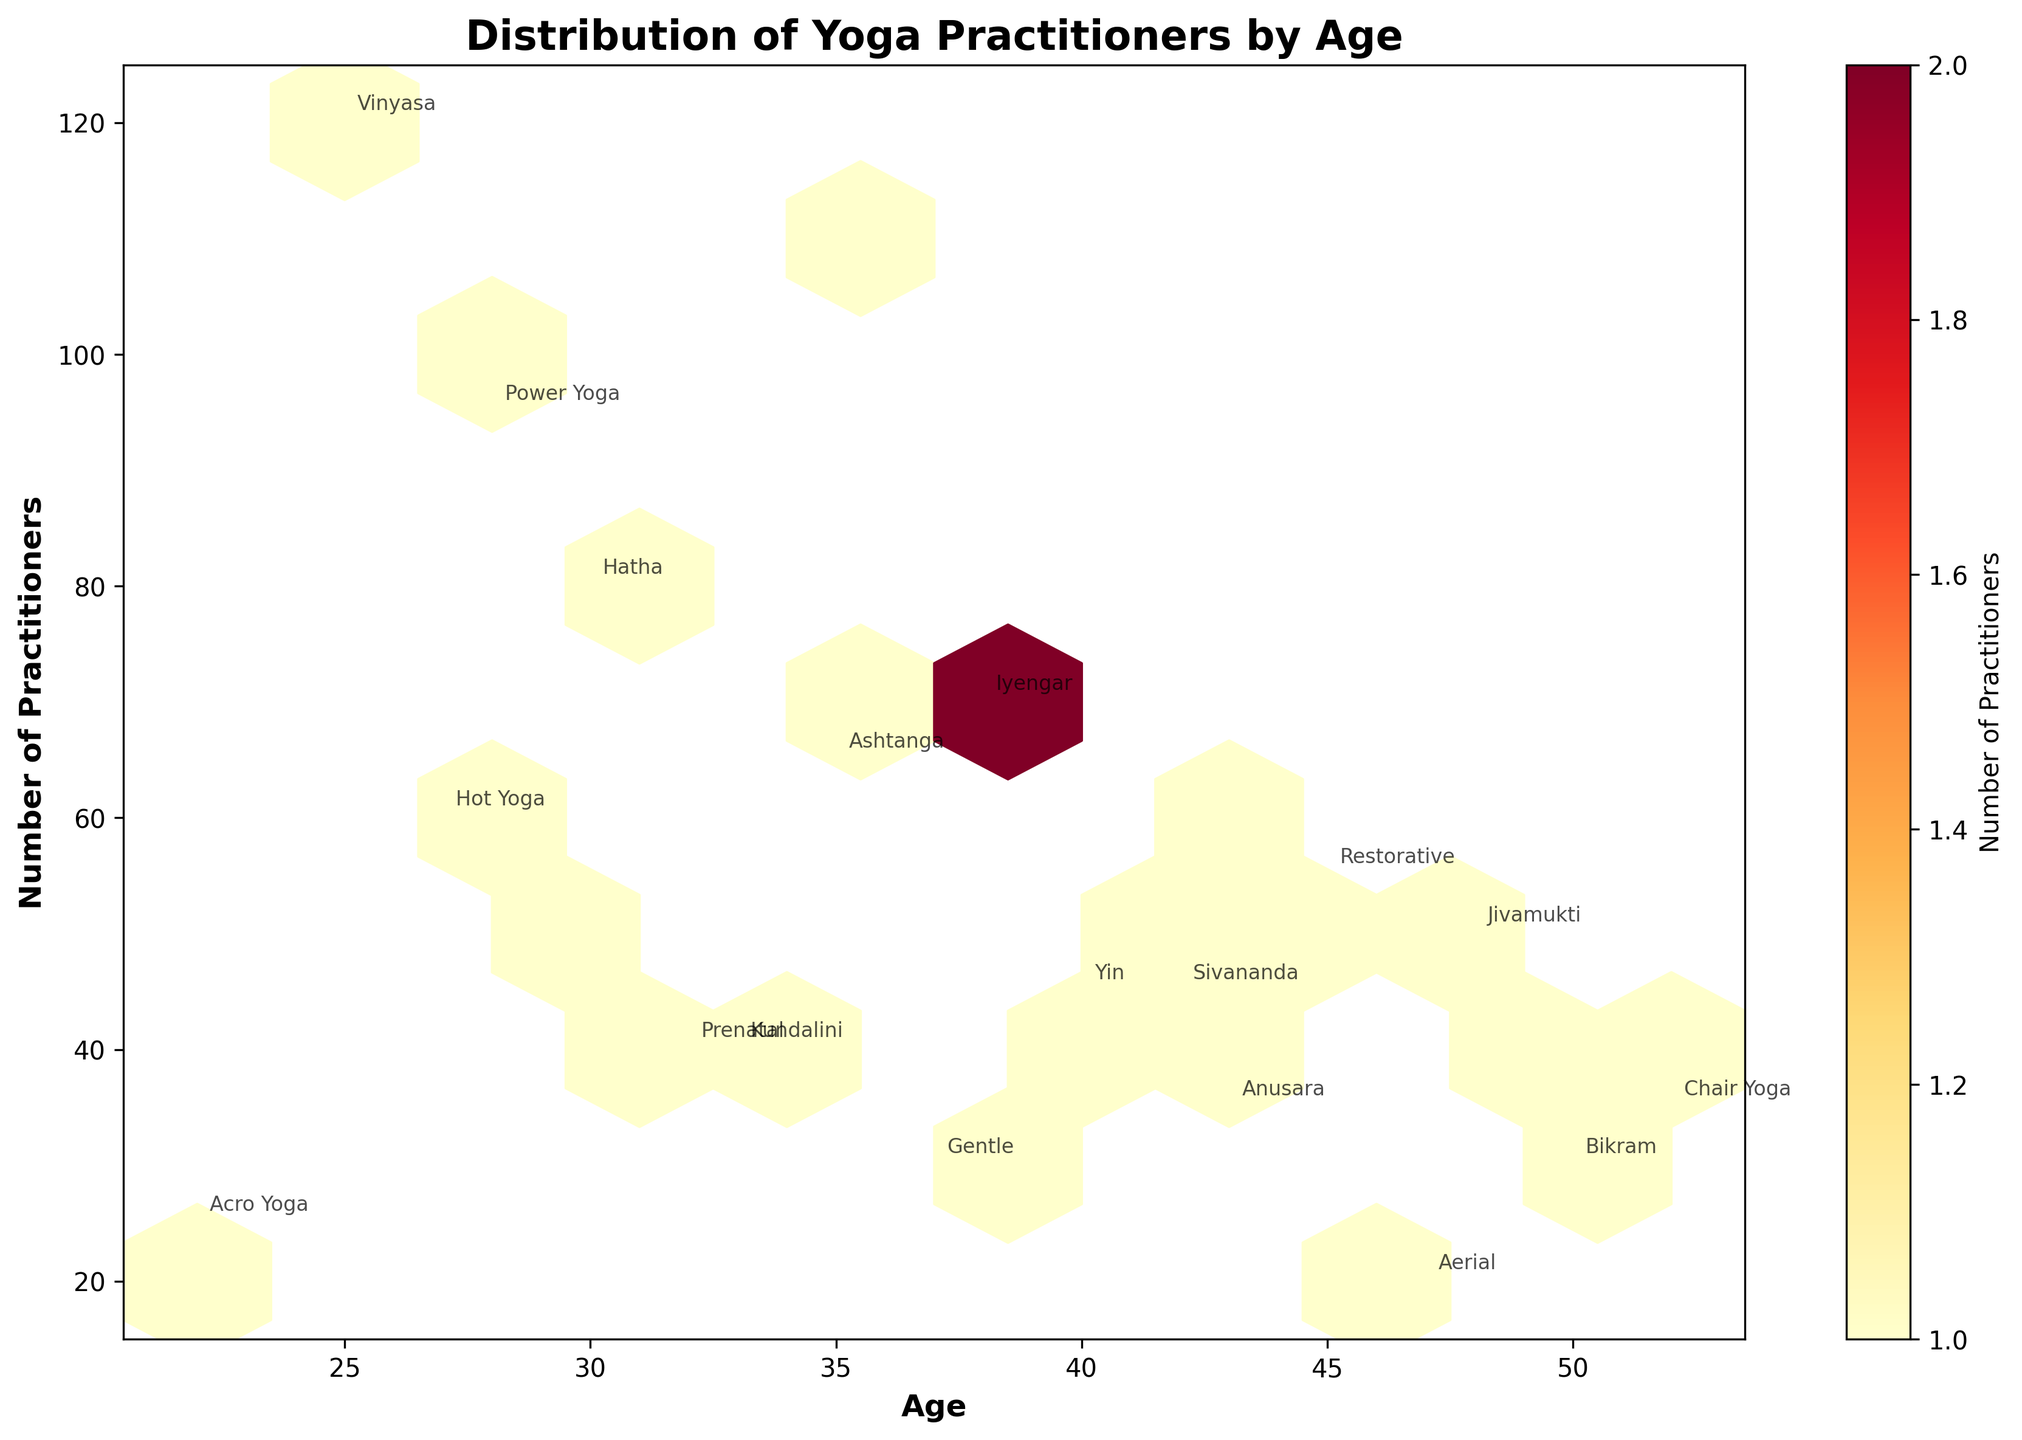What's the title of the figure? The title is a straightforward aspect of the plot, usually found at the top. By observing the figure, the text at the top reads “Distribution of Yoga Practitioners by Age”.
Answer: Distribution of Yoga Practitioners by Age What are the labels on the X and Y axes? X and Y axis labels provide specific information about the variables being plotted. We can see on the figure that the X axis is labeled “Age” and the Y axis is labeled “Number of Practitioners”.
Answer: Age and Number of Practitioners What color indicates the highest density of practitioners? The color scheme ranges from lighter to darker shades. The highest density in this plot is shown in the darkest shade, which is a deep red (from the 'YlOrRd' colormap).
Answer: Deep Red At what age is the highest number of practitioners for Vinyasa yoga? By locating the annotation for "Vinyasa" and then tracing vertically to the "Age" axis, we find it at age 25, where the practitioners value reads as 120.
Answer: 25 How does the number of Hatha practitioners at age 30 compare to Ashtanga practitioners at age 35? Locate the annotations for Hatha and Ashtanga, compare their corresponding "Number of Practitioners". Hatha at age 30 has 80 practitioners, whereas Ashtanga at age 35 has 65 practitioners.
Answer: Hatha at age 30 has more practitioners than Ashtanga at age 35 What is the average number of practitioners across all styles for individuals aged 40 and above? Ages 40 and above include 40, 42, 43, 44, 45, 47, 48, 49, 50, and 52. Summing up the practitioners (45+45+35+60+55+20+50+40+30+35) yields 415. There are 10 data points, so the average is 415/10.
Answer: 41.5 Are there more female practitioners or male practitioners overall? Count the number of female and male practitioners, then sum each group. Females: (120+65+55+95+70+50+25+40+45+110+60+35) = 830. Males: (80+45+30+40+35+60+30+20+55+70&40) = 505.
Answer: There are more female practitioners Which yoga style has the least number of practitioners, and what is the number? Locate the annotations and compare the number of practitioners. "Aerial" has the least at 20 practitioners.
Answer: Aerial has 20 practitioners How does the number of practitioners of Yin yoga at age 40 compare to Iyengar at age 38? Looking at the figure, Yin yoga practitioners at age 40 is 45; Iyengar at age 38 is 70.
Answer: Iyengar at age 38 has more practitioners than Yin at age 40 In which age group does the practice of Restorative yoga have more practitioners, age 45 or age 49? Comparing the annotations for Restorative at ages 45 and 49, we see that age 45 has 55 practitioners, while age 49 has 40 practitioners.
Answer: Age 45 has more practitioners 